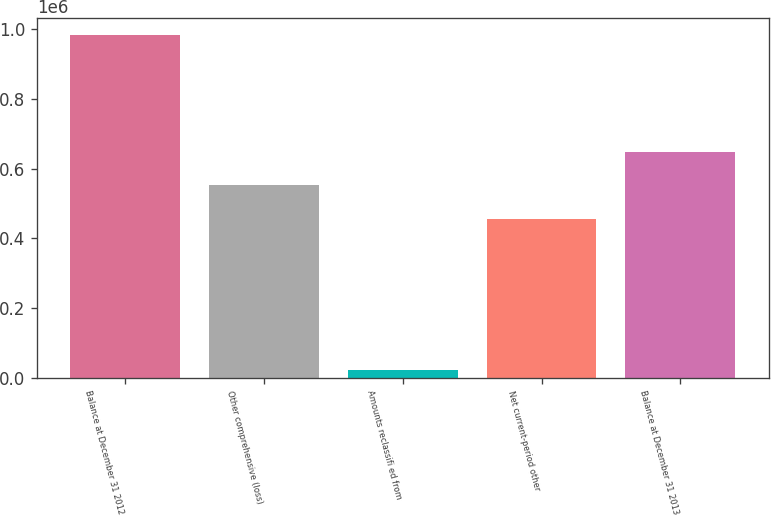Convert chart. <chart><loc_0><loc_0><loc_500><loc_500><bar_chart><fcel>Balance at December 31 2012<fcel>Other comprehensive (loss)<fcel>Amounts reclassifi ed from<fcel>Net current-period other<fcel>Balance at December 31 2013<nl><fcel>981879<fcel>551691<fcel>23045<fcel>455808<fcel>647575<nl></chart> 